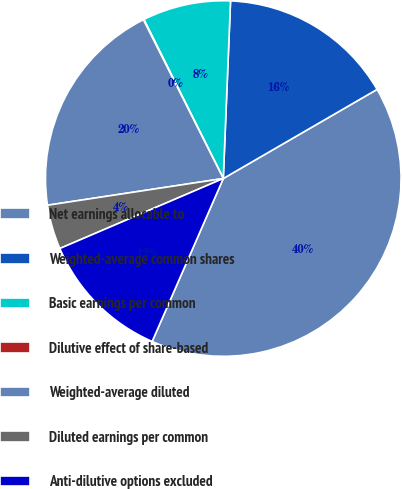Convert chart to OTSL. <chart><loc_0><loc_0><loc_500><loc_500><pie_chart><fcel>Net earnings allocable to<fcel>Weighted-average common shares<fcel>Basic earnings per common<fcel>Dilutive effect of share-based<fcel>Weighted-average diluted<fcel>Diluted earnings per common<fcel>Anti-dilutive options excluded<nl><fcel>39.91%<fcel>15.99%<fcel>8.02%<fcel>0.05%<fcel>19.98%<fcel>4.04%<fcel>12.01%<nl></chart> 